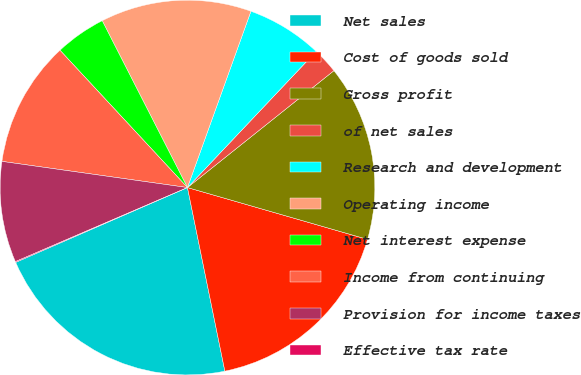<chart> <loc_0><loc_0><loc_500><loc_500><pie_chart><fcel>Net sales<fcel>Cost of goods sold<fcel>Gross profit<fcel>of net sales<fcel>Research and development<fcel>Operating income<fcel>Net interest expense<fcel>Income from continuing<fcel>Provision for income taxes<fcel>Effective tax rate<nl><fcel>21.66%<fcel>17.34%<fcel>15.18%<fcel>2.23%<fcel>6.55%<fcel>13.02%<fcel>4.39%<fcel>10.86%<fcel>8.7%<fcel>0.07%<nl></chart> 